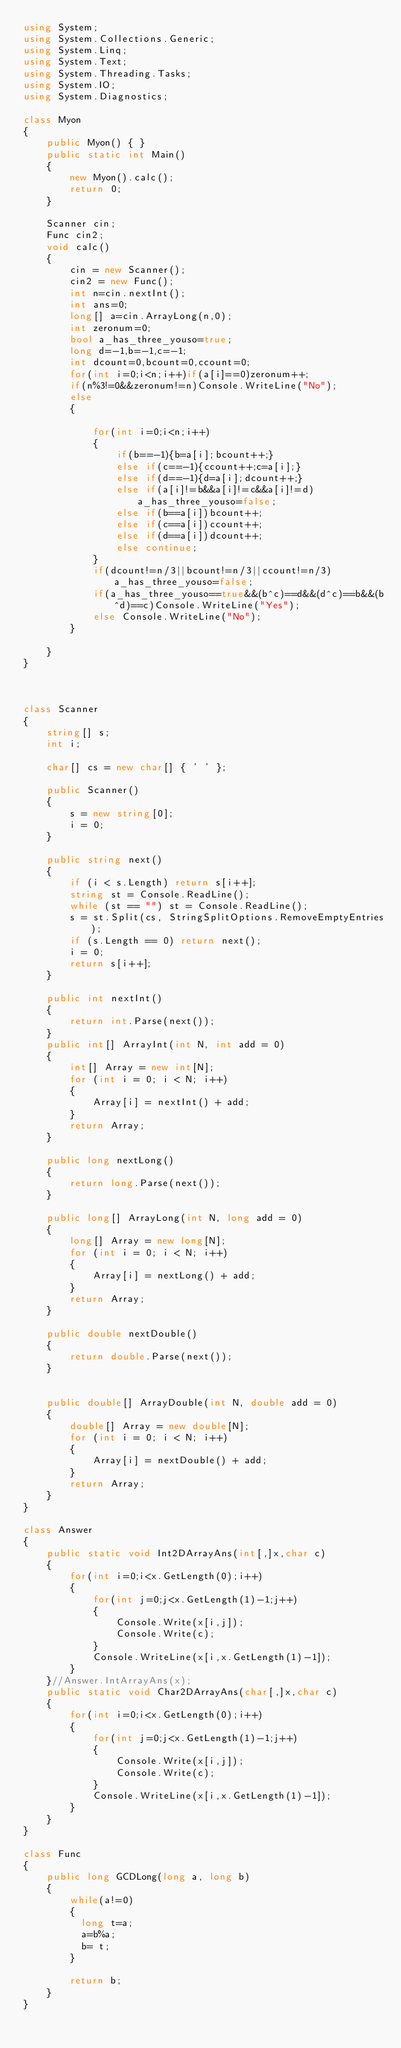Convert code to text. <code><loc_0><loc_0><loc_500><loc_500><_C#_>using System;
using System.Collections.Generic;
using System.Linq;
using System.Text;
using System.Threading.Tasks;
using System.IO;
using System.Diagnostics;

class Myon
{
    public Myon() { }
    public static int Main()
    {
        new Myon().calc();
        return 0;
    }

    Scanner cin;
    Func cin2;
    void calc()
    {
        cin = new Scanner();
        cin2 = new Func();
        int n=cin.nextInt();
        int ans=0;
        long[] a=cin.ArrayLong(n,0);
        int zeronum=0;
        bool a_has_three_youso=true;
        long d=-1,b=-1,c=-1;
        int dcount=0,bcount=0,ccount=0;
        for(int i=0;i<n;i++)if(a[i]==0)zeronum++;
        if(n%3!=0&&zeronum!=n)Console.WriteLine("No");
        else
        {
            
            for(int i=0;i<n;i++)
            {
                if(b==-1){b=a[i];bcount++;}
                else if(c==-1){ccount++;c=a[i];}
                else if(d==-1){d=a[i];dcount++;}
                else if(a[i]!=b&&a[i]!=c&&a[i]!=d)a_has_three_youso=false;
                else if(b==a[i])bcount++;
                else if(c==a[i])ccount++;
                else if(d==a[i])dcount++;
                else continue;
            }
            if(dcount!=n/3||bcount!=n/3||ccount!=n/3)a_has_three_youso=false;
            if(a_has_three_youso==true&&(b^c)==d&&(d^c)==b&&(b^d)==c)Console.WriteLine("Yes");
            else Console.WriteLine("No");
        }
        
    }
}



class Scanner
{
    string[] s;
    int i;

    char[] cs = new char[] { ' ' };

    public Scanner()
    {
        s = new string[0];
        i = 0;
    }

    public string next()
    {
        if (i < s.Length) return s[i++];
        string st = Console.ReadLine();
        while (st == "") st = Console.ReadLine();
        s = st.Split(cs, StringSplitOptions.RemoveEmptyEntries);
        if (s.Length == 0) return next();
        i = 0;
        return s[i++];
    }

    public int nextInt()
    {
        return int.Parse(next());
    }
    public int[] ArrayInt(int N, int add = 0)
    {
        int[] Array = new int[N];
        for (int i = 0; i < N; i++)
        {
            Array[i] = nextInt() + add;
        }
        return Array;
    }

    public long nextLong()
    {
        return long.Parse(next());
    }

    public long[] ArrayLong(int N, long add = 0)
    {
        long[] Array = new long[N];
        for (int i = 0; i < N; i++)
        {
            Array[i] = nextLong() + add;
        }
        return Array;
    }

    public double nextDouble()
    {
        return double.Parse(next());
    }


    public double[] ArrayDouble(int N, double add = 0)
    {
        double[] Array = new double[N];
        for (int i = 0; i < N; i++)
        {
            Array[i] = nextDouble() + add;
        }
        return Array;
    }
}

class Answer
{
    public static void Int2DArrayAns(int[,]x,char c)
    {
        for(int i=0;i<x.GetLength(0);i++)
        {
            for(int j=0;j<x.GetLength(1)-1;j++)
            {
                Console.Write(x[i,j]);
                Console.Write(c);
            }
            Console.WriteLine(x[i,x.GetLength(1)-1]);
        }
    }//Answer.IntArrayAns(x);
    public static void Char2DArrayAns(char[,]x,char c)
    {
        for(int i=0;i<x.GetLength(0);i++)
        {
            for(int j=0;j<x.GetLength(1)-1;j++)
            {
                Console.Write(x[i,j]);
                Console.Write(c);
            }
            Console.WriteLine(x[i,x.GetLength(1)-1]);
        }
    }
}

class Func
{
    public long GCDLong(long a, long b)
    {
        while(a!=0)
        {
          long t=a;
          a=b%a;
          b= t;
        }
      
        return b;        
    }
}



</code> 